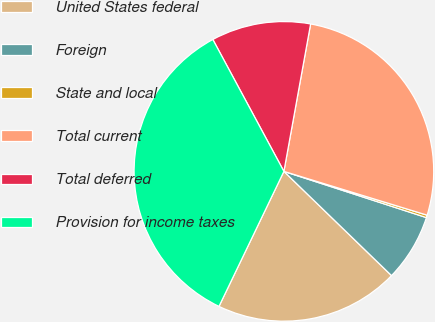Convert chart. <chart><loc_0><loc_0><loc_500><loc_500><pie_chart><fcel>United States federal<fcel>Foreign<fcel>State and local<fcel>Total current<fcel>Total deferred<fcel>Provision for income taxes<nl><fcel>19.89%<fcel>7.25%<fcel>0.27%<fcel>26.87%<fcel>10.72%<fcel>35.0%<nl></chart> 